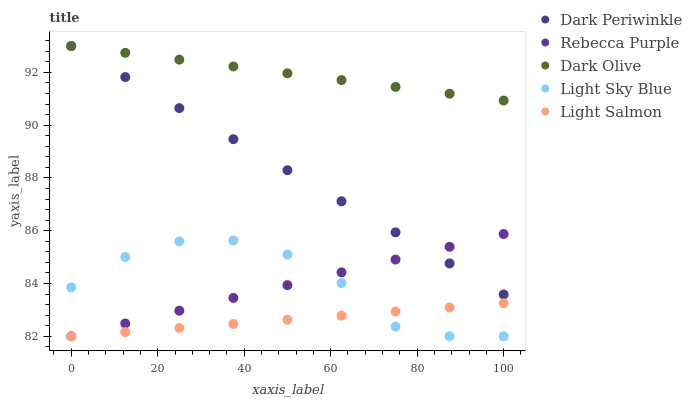Does Light Salmon have the minimum area under the curve?
Answer yes or no. Yes. Does Dark Olive have the maximum area under the curve?
Answer yes or no. Yes. Does Dark Periwinkle have the minimum area under the curve?
Answer yes or no. No. Does Dark Periwinkle have the maximum area under the curve?
Answer yes or no. No. Is Dark Olive the smoothest?
Answer yes or no. Yes. Is Light Sky Blue the roughest?
Answer yes or no. Yes. Is Dark Periwinkle the smoothest?
Answer yes or no. No. Is Dark Periwinkle the roughest?
Answer yes or no. No. Does Light Salmon have the lowest value?
Answer yes or no. Yes. Does Dark Periwinkle have the lowest value?
Answer yes or no. No. Does Dark Periwinkle have the highest value?
Answer yes or no. Yes. Does Light Sky Blue have the highest value?
Answer yes or no. No. Is Light Salmon less than Dark Olive?
Answer yes or no. Yes. Is Dark Olive greater than Light Sky Blue?
Answer yes or no. Yes. Does Light Salmon intersect Light Sky Blue?
Answer yes or no. Yes. Is Light Salmon less than Light Sky Blue?
Answer yes or no. No. Is Light Salmon greater than Light Sky Blue?
Answer yes or no. No. Does Light Salmon intersect Dark Olive?
Answer yes or no. No. 